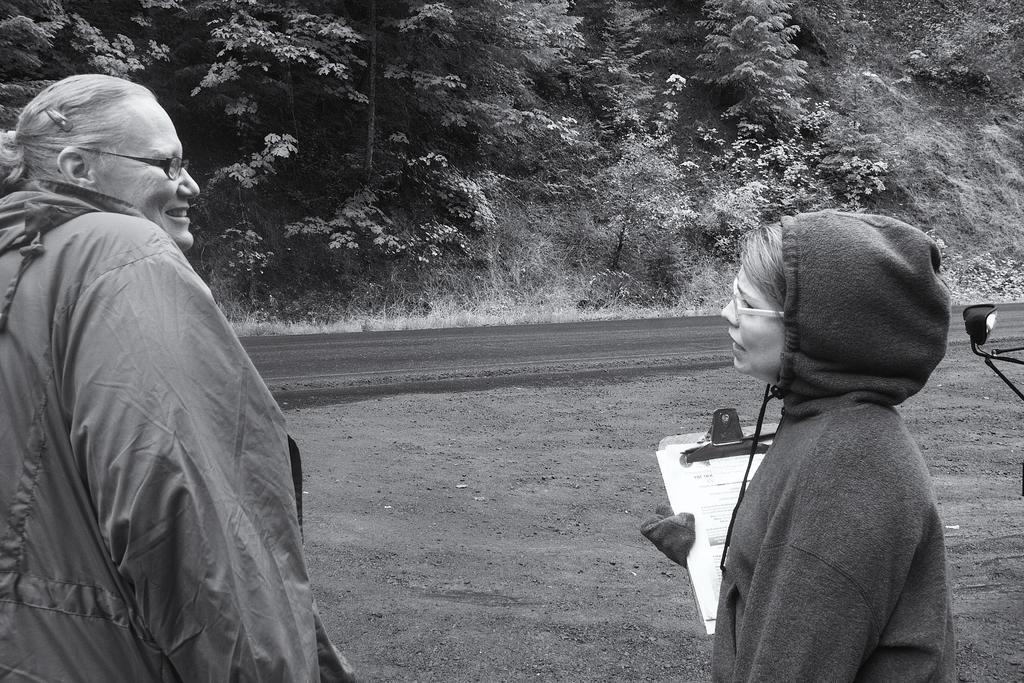How many people are present in the image? There are two persons standing in the image. What is one person doing with their hands? One person is holding an object. What type of natural environment can be seen in the image? There are trees, plants, and grass in the image. What type of brick wall can be seen in the image? There is no brick wall present in the image. What type of spy equipment can be seen in the image? There is no spy equipment present in the image. 